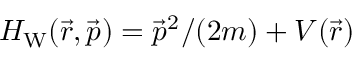<formula> <loc_0><loc_0><loc_500><loc_500>{ H _ { W } ( \vec { r } , \vec { p } ) = \vec { p } ^ { 2 } / ( 2 m ) + V ( \vec { r } ) }</formula> 